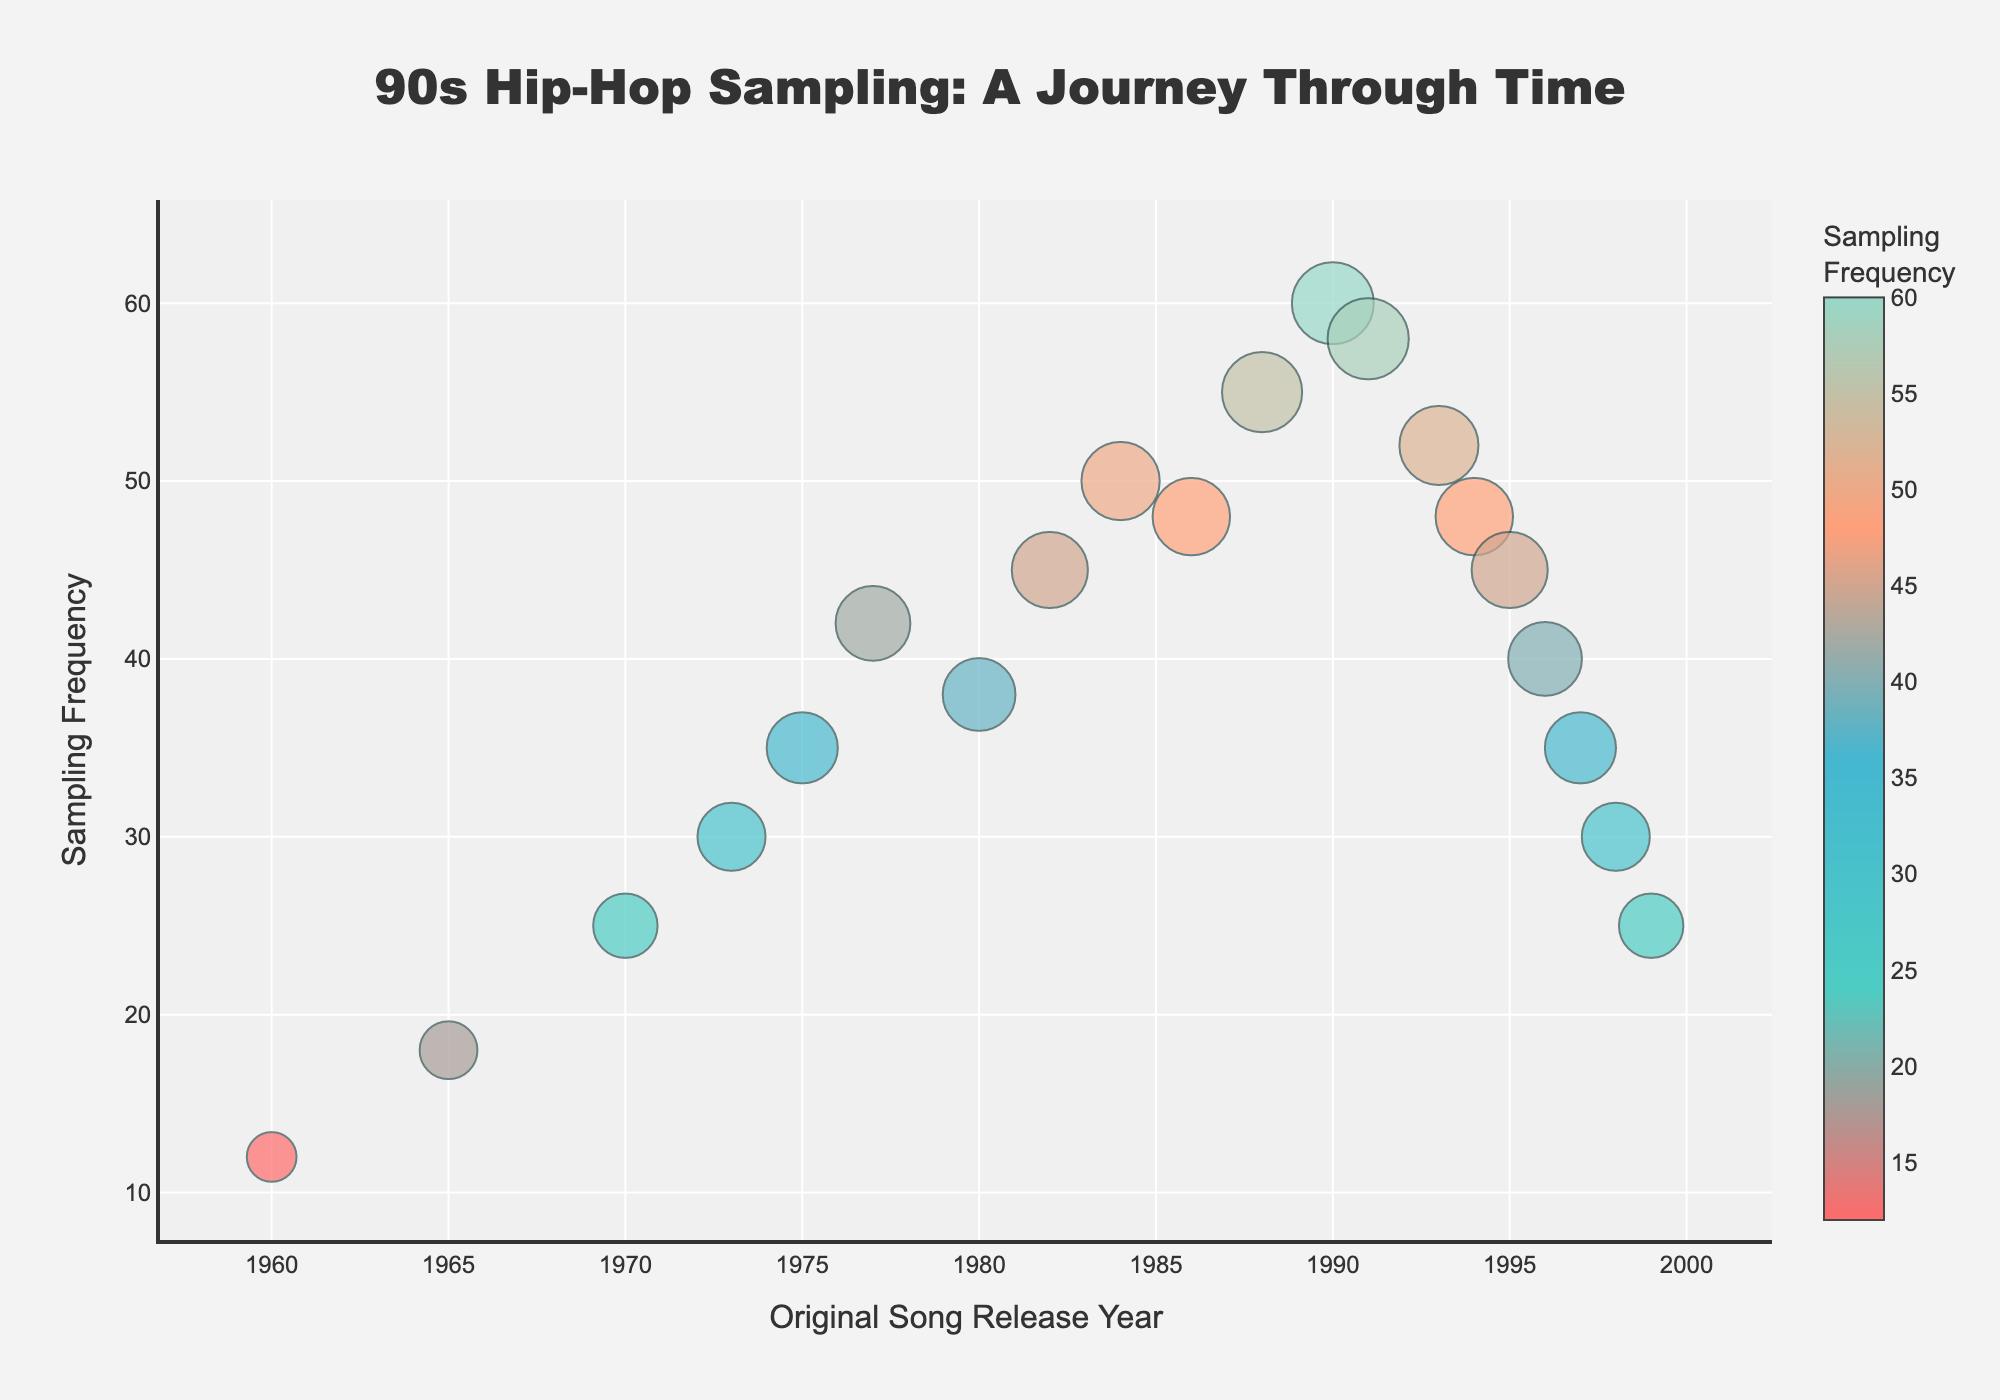What's the title of the plot? The title is prominently displayed at the top of the plot, summarizing its main theme.
Answer: 90s Hip-Hop Sampling: A Journey Through Time What is the song with the highest sampling frequency? By examining the y-axis, the song represented by the highest marker corresponds to the highest frequency.
Answer: A Tribe Called Quest - Can I Kick It? How does the sampling frequency of "Afrika Bambaataa - Planet Rock" compare to that of "A Tribe Called Quest - Can I Kick It?" "Afrika Bambaataa - Planet Rock" has a frequency of 45, while "A Tribe Called Quest - Can I Kick It?" has a frequency of 60, which means the latter has a higher frequency.
Answer: "A Tribe Called Quest - Can I Kick It?" has a higher frequency Which decade has the most sampled songs according to the plot? By grouping the songs by decade, count the number of markers in each decade's range on the x-axis. The 1980s and 1990s both have a significant number of sampled songs, but the plot focuses on the 90s tracks, indicating the late 80s to 90s period is heavily sampled.
Answer: 1990s What's the average sampling frequency of the songs released in the 1980s? Songs from the 1980s have frequencies of 45, 50, and 48. Adding these gives 143, and dividing by the number of songs (3) provides the average.
Answer: 47.67 Which song from the 1970s has the highest sampling frequency, and what is it? Examine the highest markers within the 1970s range on the x-axis.
Answer: Curtis Mayfield - Pusherman with a frequency of 30 What is the sampling frequency difference between "Run-DMC - Rock Box" and "Lauryn Hill - Doo Wop (That Thing)"? The frequency of "Run-DMC - Rock Box" is 50 and "Lauryn Hill - Doo Wop (That Thing)" is 30. Subtract the smaller from the larger to find the difference.
Answer: 20 How many songs have a sampling frequency greater than 50? Identify the markers with y-values exceeding 50 and count them.
Answer: 3 What year had the most samples according to the frequency data, and how many samples did it have? Look for the maximum y-value on the plot, then find the corresponding x-value (year) and frequency. "A Tribe Called Quest - Can I Kick It?" in 1990 has the highest frequency.
Answer: 1990, 60 What's the trend in sampling frequency as the years progress from the 1960s to the 1990s? Observe the plot to see if the frequencies generally increase, decrease, or show fluctuation over time. The trend appears to increase with a peak in the early 1990s before a slight decline.
Answer: Increasing, peaking in the early 1990s 